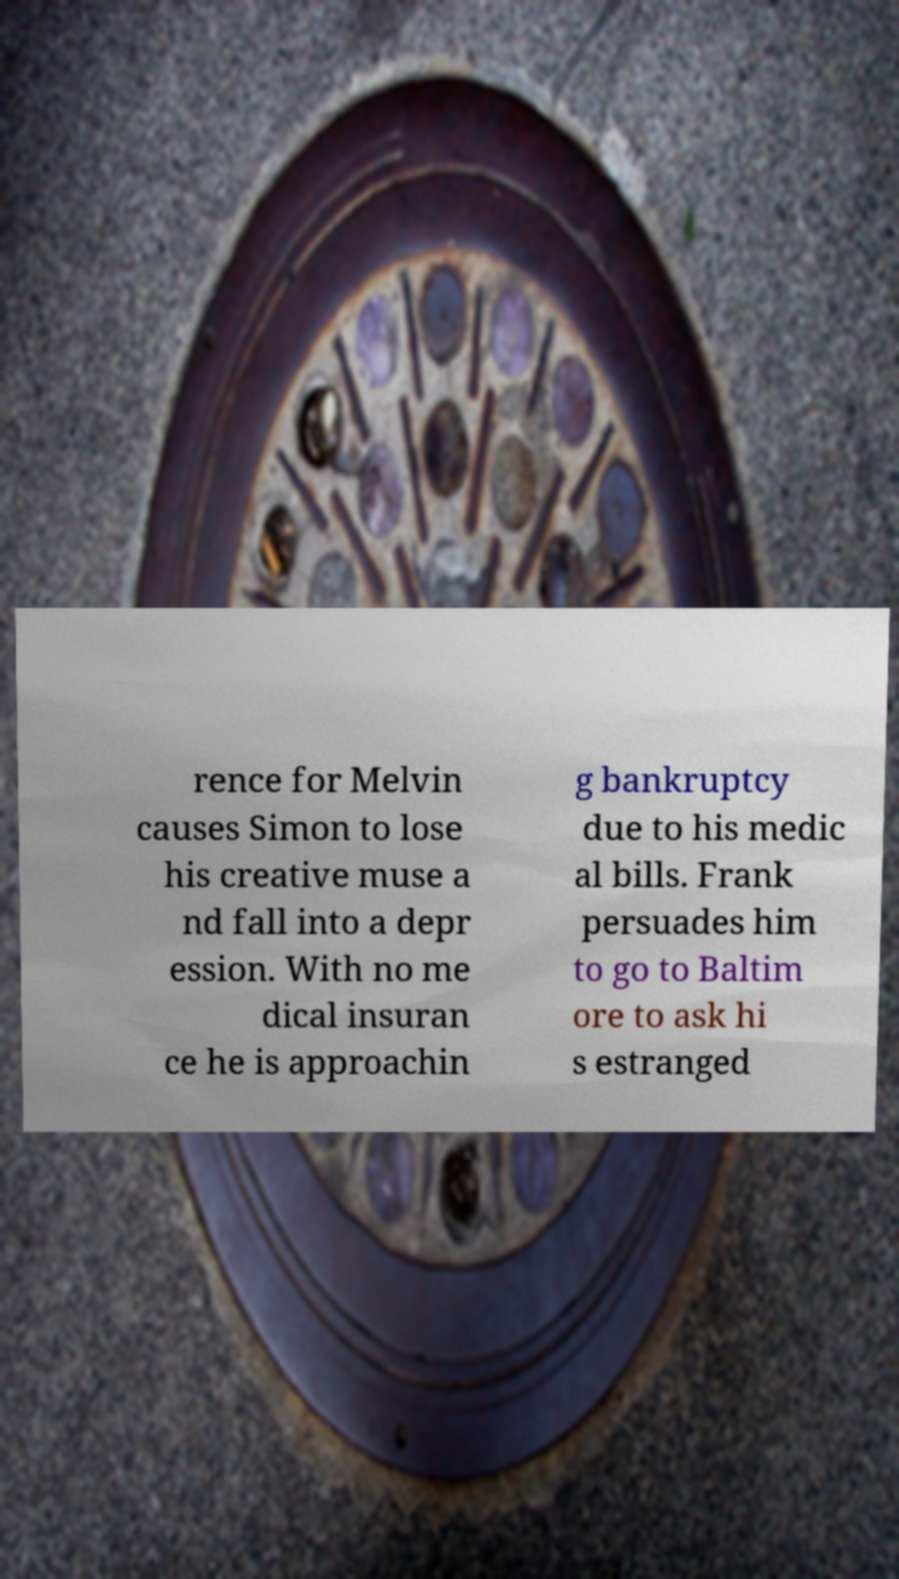For documentation purposes, I need the text within this image transcribed. Could you provide that? rence for Melvin causes Simon to lose his creative muse a nd fall into a depr ession. With no me dical insuran ce he is approachin g bankruptcy due to his medic al bills. Frank persuades him to go to Baltim ore to ask hi s estranged 